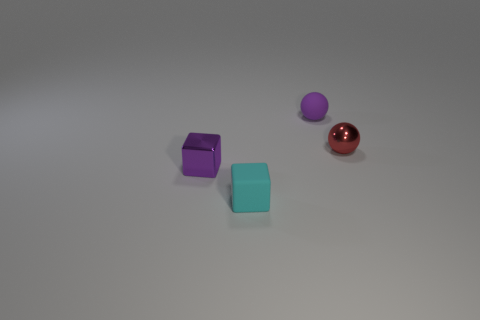Add 2 small purple shiny cubes. How many objects exist? 6 Add 3 red metallic objects. How many red metallic objects are left? 4 Add 1 metal cubes. How many metal cubes exist? 2 Subtract 0 purple cylinders. How many objects are left? 4 Subtract all red metallic things. Subtract all small red metallic objects. How many objects are left? 2 